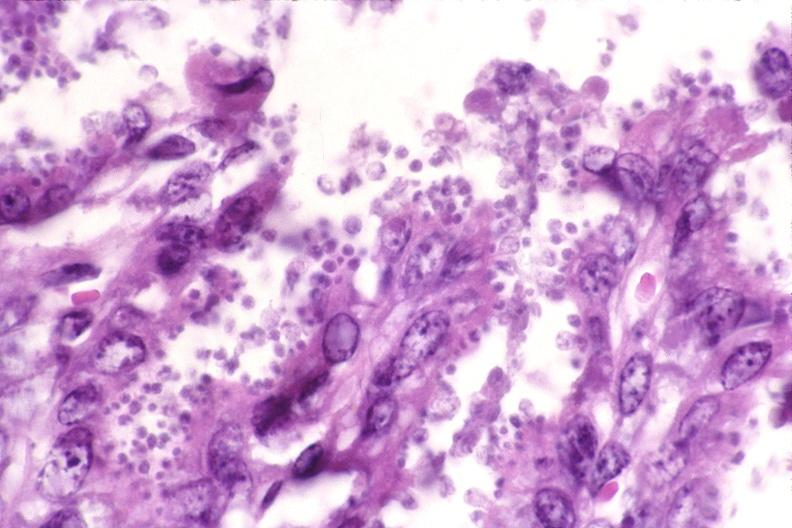what is present?
Answer the question using a single word or phrase. Gastrointestinal 